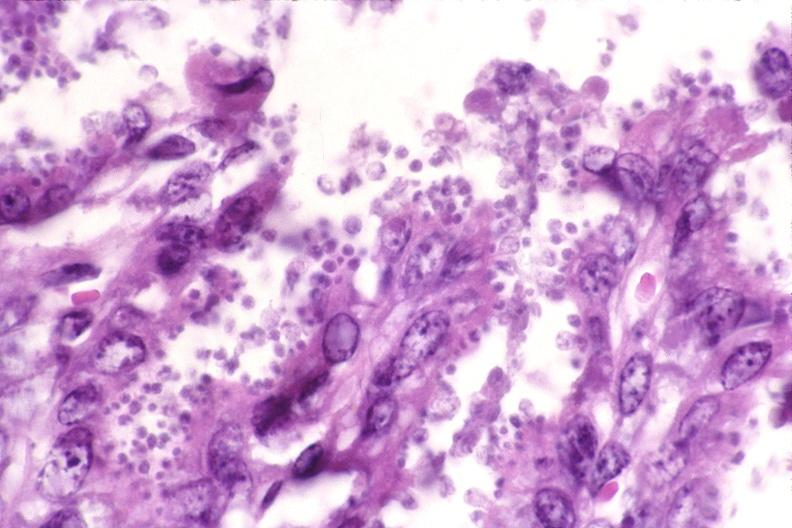what is present?
Answer the question using a single word or phrase. Gastrointestinal 